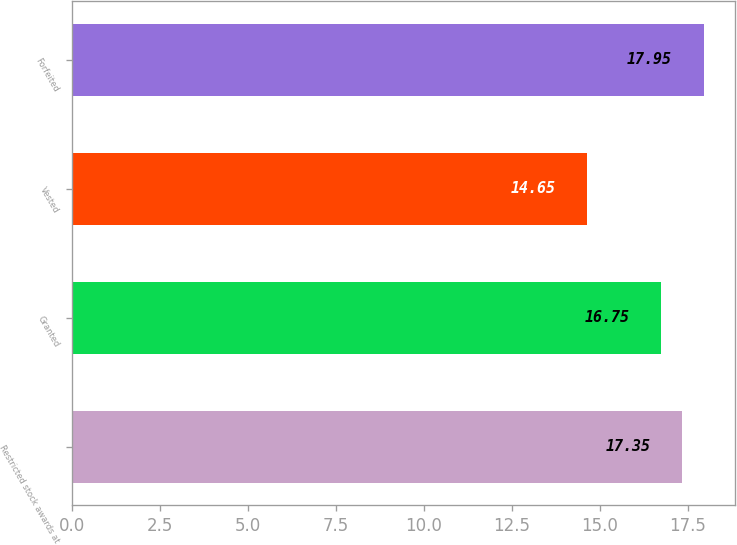Convert chart to OTSL. <chart><loc_0><loc_0><loc_500><loc_500><bar_chart><fcel>Restricted stock awards at<fcel>Granted<fcel>Vested<fcel>Forfeited<nl><fcel>17.35<fcel>16.75<fcel>14.65<fcel>17.95<nl></chart> 